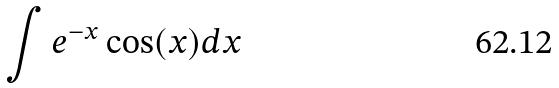<formula> <loc_0><loc_0><loc_500><loc_500>\int e ^ { - x } \cos ( x ) d x</formula> 